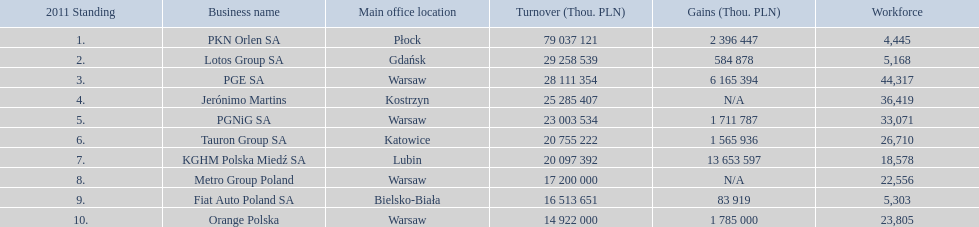How many companies had over $1,000,000 profit? 6. 